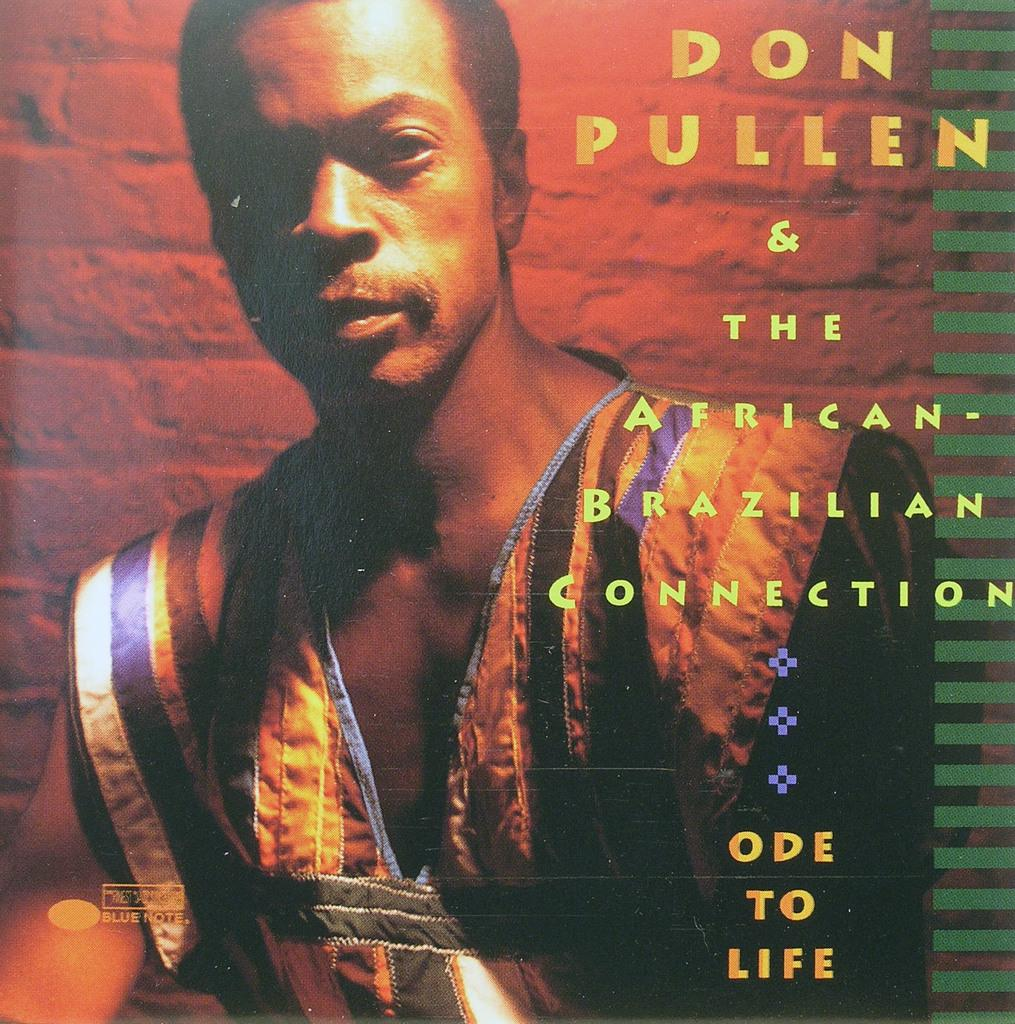<image>
Relay a brief, clear account of the picture shown. Don Pullen & the African Brazilian connection cd cover 